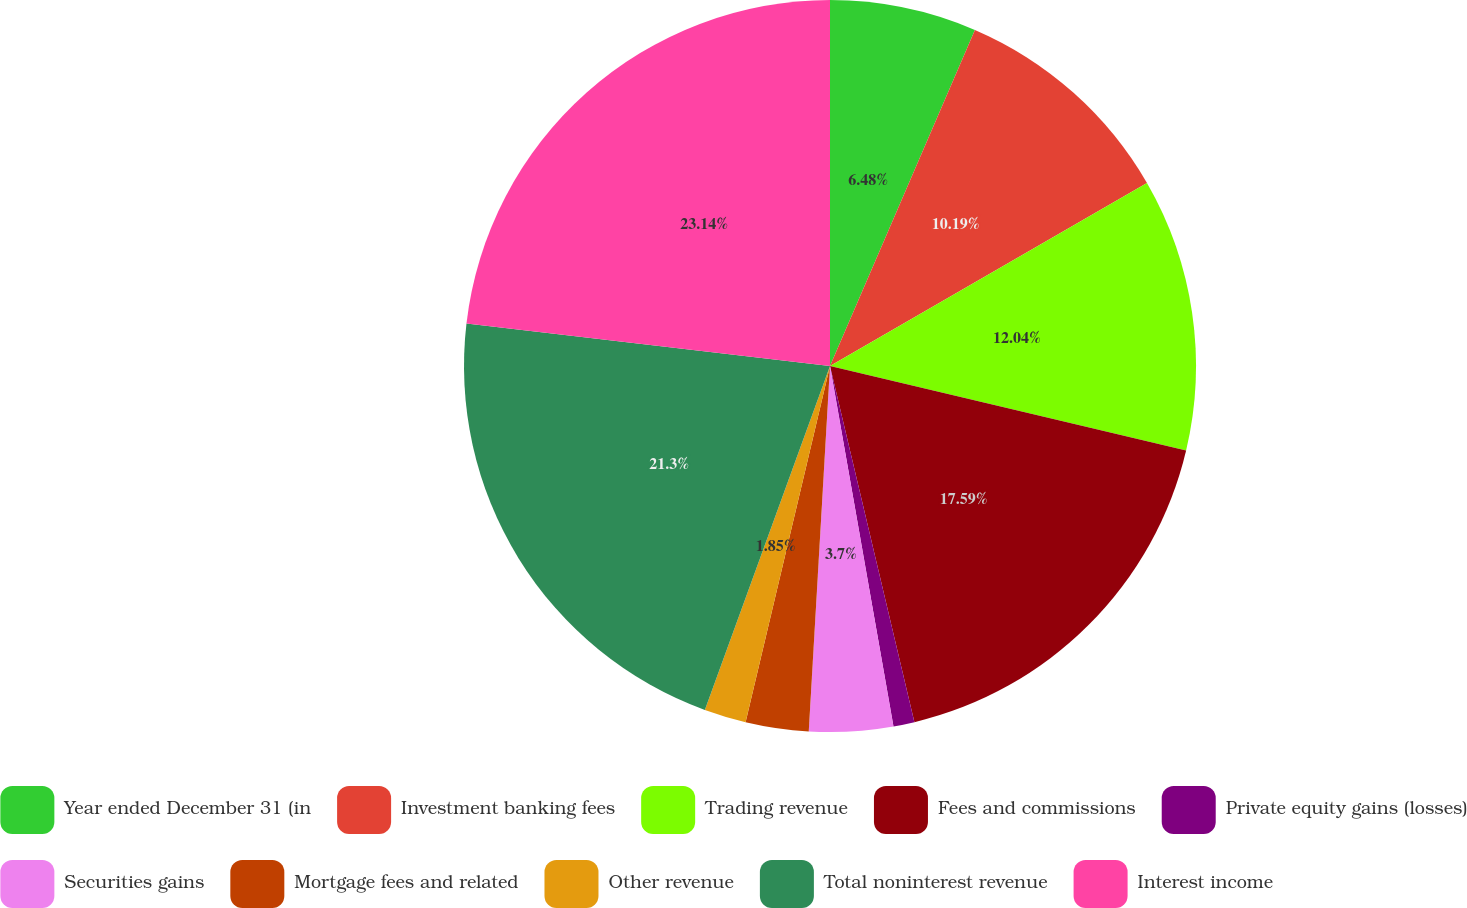<chart> <loc_0><loc_0><loc_500><loc_500><pie_chart><fcel>Year ended December 31 (in<fcel>Investment banking fees<fcel>Trading revenue<fcel>Fees and commissions<fcel>Private equity gains (losses)<fcel>Securities gains<fcel>Mortgage fees and related<fcel>Other revenue<fcel>Total noninterest revenue<fcel>Interest income<nl><fcel>6.48%<fcel>10.19%<fcel>12.04%<fcel>17.59%<fcel>0.93%<fcel>3.7%<fcel>2.78%<fcel>1.85%<fcel>21.3%<fcel>23.15%<nl></chart> 